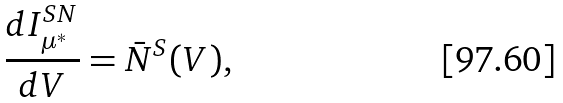<formula> <loc_0><loc_0><loc_500><loc_500>\frac { d I ^ { S N } _ { \mu ^ { * } } } { d V } = \bar { N } ^ { S } ( V ) ,</formula> 